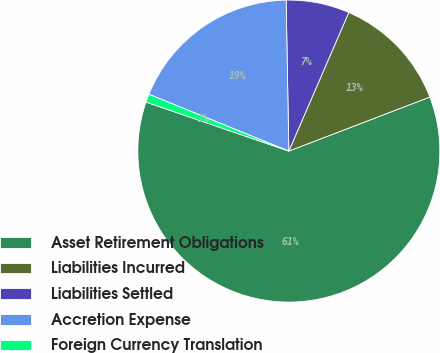Convert chart to OTSL. <chart><loc_0><loc_0><loc_500><loc_500><pie_chart><fcel>Asset Retirement Obligations<fcel>Liabilities Incurred<fcel>Liabilities Settled<fcel>Accretion Expense<fcel>Foreign Currency Translation<nl><fcel>61.08%<fcel>12.68%<fcel>6.78%<fcel>18.58%<fcel>0.88%<nl></chart> 